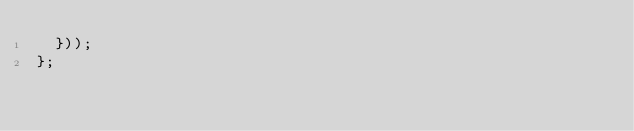Convert code to text. <code><loc_0><loc_0><loc_500><loc_500><_JavaScript_>  }));
};
</code> 